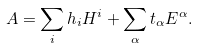Convert formula to latex. <formula><loc_0><loc_0><loc_500><loc_500>A = \sum _ { i } h _ { i } H ^ { i } + \sum _ { \alpha } t _ { \alpha } E ^ { \alpha } .</formula> 